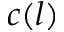Convert formula to latex. <formula><loc_0><loc_0><loc_500><loc_500>c ( l )</formula> 